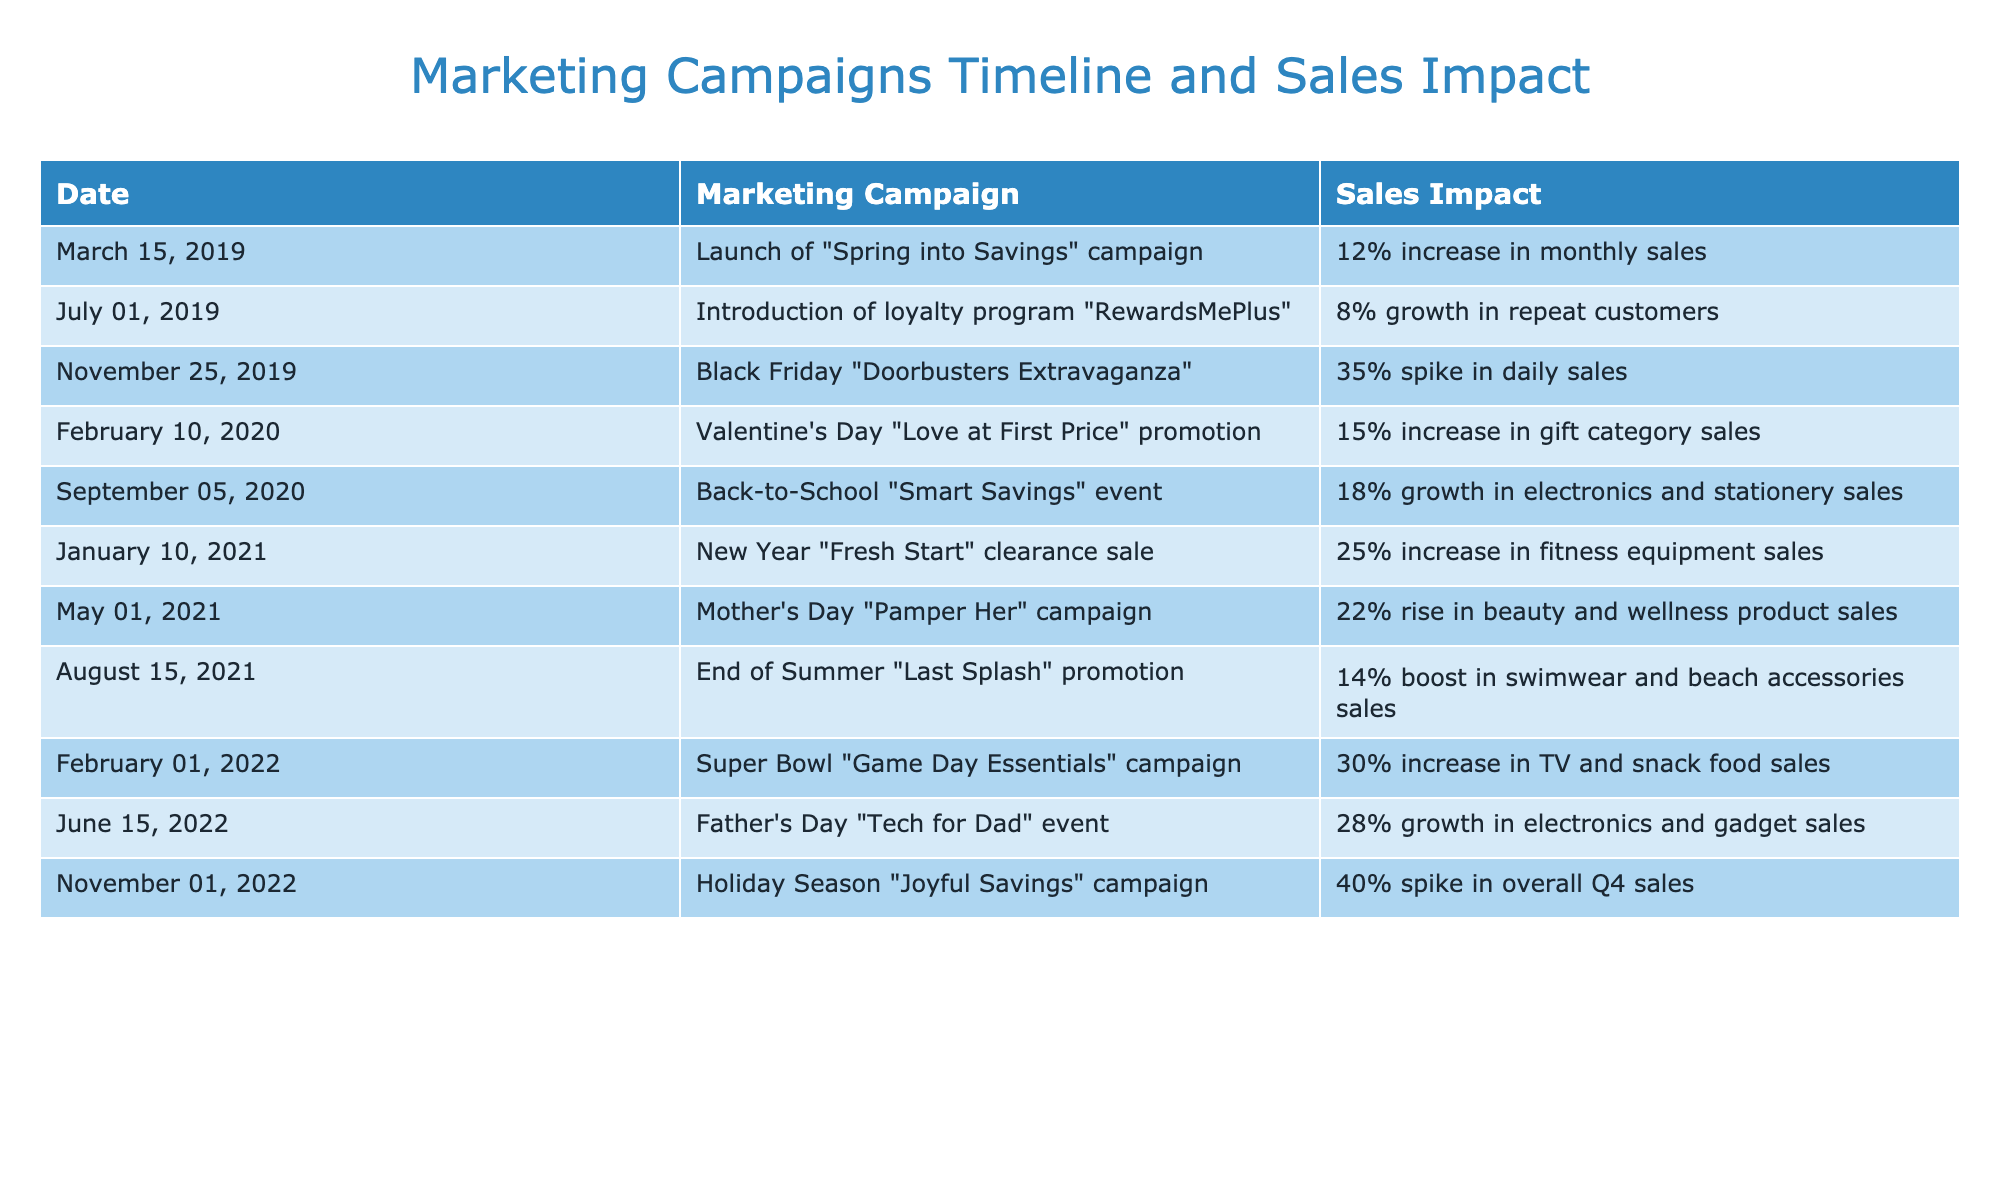What was the sales impact of the "Black Friday Doorbusters Extravaganza"? The table indicates that the "Black Friday Doorbusters Extravaganza" event led to a 35% spike in daily sales. Thus, the specific sales impact of this campaign is directly referenced in the table.
Answer: 35% spike in daily sales Which marketing campaign resulted in the highest increase in sales? By scanning the impact column, the "Holiday Season Joyful Savings" campaign shows a 40% spike in overall Q4 sales, which is the highest figure listed in the table.
Answer: Holiday Season "Joyful Savings" campaign Was there any marketing campaign that increased sales by more than 20%? Looking through the impact figures, the campaigns "Black Friday Doorbusters Extravaganza," "Holiday Season Joyful Savings," and "Father's Day Tech for Dad" achieved increases of 35%, 40%, and 28% respectively, all exceeding 20%. Therefore, the answer is yes.
Answer: Yes What is the average sales increase percentage of the campaigns launched between 2019 and 2020? The sales impact from campaigns in that period are 12%, 8%, 35%, 15%, and 18%. First, we sum these: (12 + 8 + 35 + 15 + 18) = 88%. Then, we divide by the number of campaigns (5): 88%/5 = 17.6%. Thus, the average sales increase is 17.6%.
Answer: 17.6% Which promotion in June had the most significant impact, and what was that impact? According to the table, the "Father's Day Tech for Dad" event in June had a 28% growth in electronics and gadget sales, marking it as the significant June promotion.
Answer: Father's Day "Tech for Dad" event, 28% growth How many campaigns mentioned led to an increase of at least 15% in sales? The campaigns that resulted in at least a 15% increase in sales are: "Spring into Savings" (12%), "Valentine's Day" (15%), "Back-to-School" (18%), "New Year" (25%), "Mother's Day" (22%), "Super Bowl" (30%), "Father's Day" (28%), and "Holiday Season" (40%). Looking through these events, seven campaigns achieved this criterion.
Answer: Seven campaigns Did any marketing campaigns positively affect electronics sales? After reviewing the table, the "Back-to-School Smart Savings" event (18% increase) and the "Father's Day Tech for Dad" event (28% growth) both positively impacted electronics sales. Thus, the answer is yes.
Answer: Yes What was the difference in sales impact between the Mother's Day and Father's Day campaigns? The Mother's Day "Pamper Her" campaign led to a 22% increase in beauty and wellness product sales, while the Father's Day "Tech for Dad" event resulted in a 28% growth in electronics sales. The difference in sales impact is 28% - 22% = 6%.
Answer: 6% What sales result did the "End of Summer Last Splash" campaign achieve? Per the table, the "End of Summer Last Splash" promotion led to a 14% boost in swimwear and beach accessories sales. This is a straightforward fact found in the sales impact column.
Answer: 14% boost in sales 